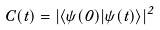<formula> <loc_0><loc_0><loc_500><loc_500>C ( t ) = \left | \langle \psi ( 0 ) | \psi ( t ) \rangle \right | ^ { 2 }</formula> 